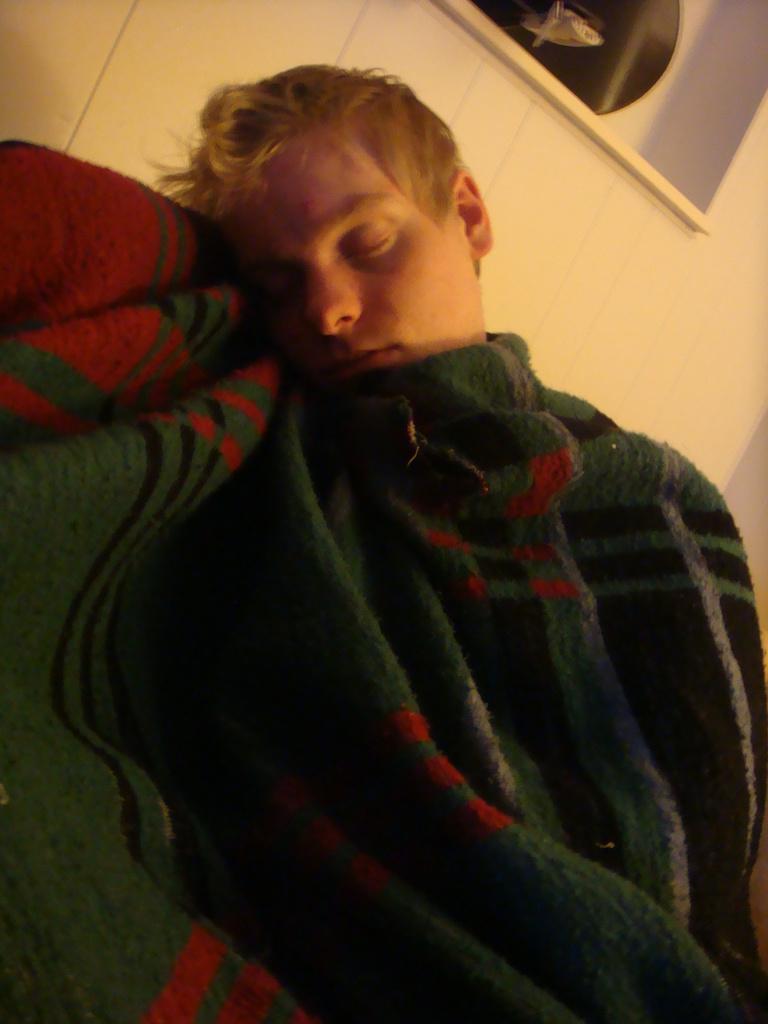Please provide a concise description of this image. In this image there is a person sleeping by covering the blanket. Behind him there is a wall with the shelf and some object on it. 